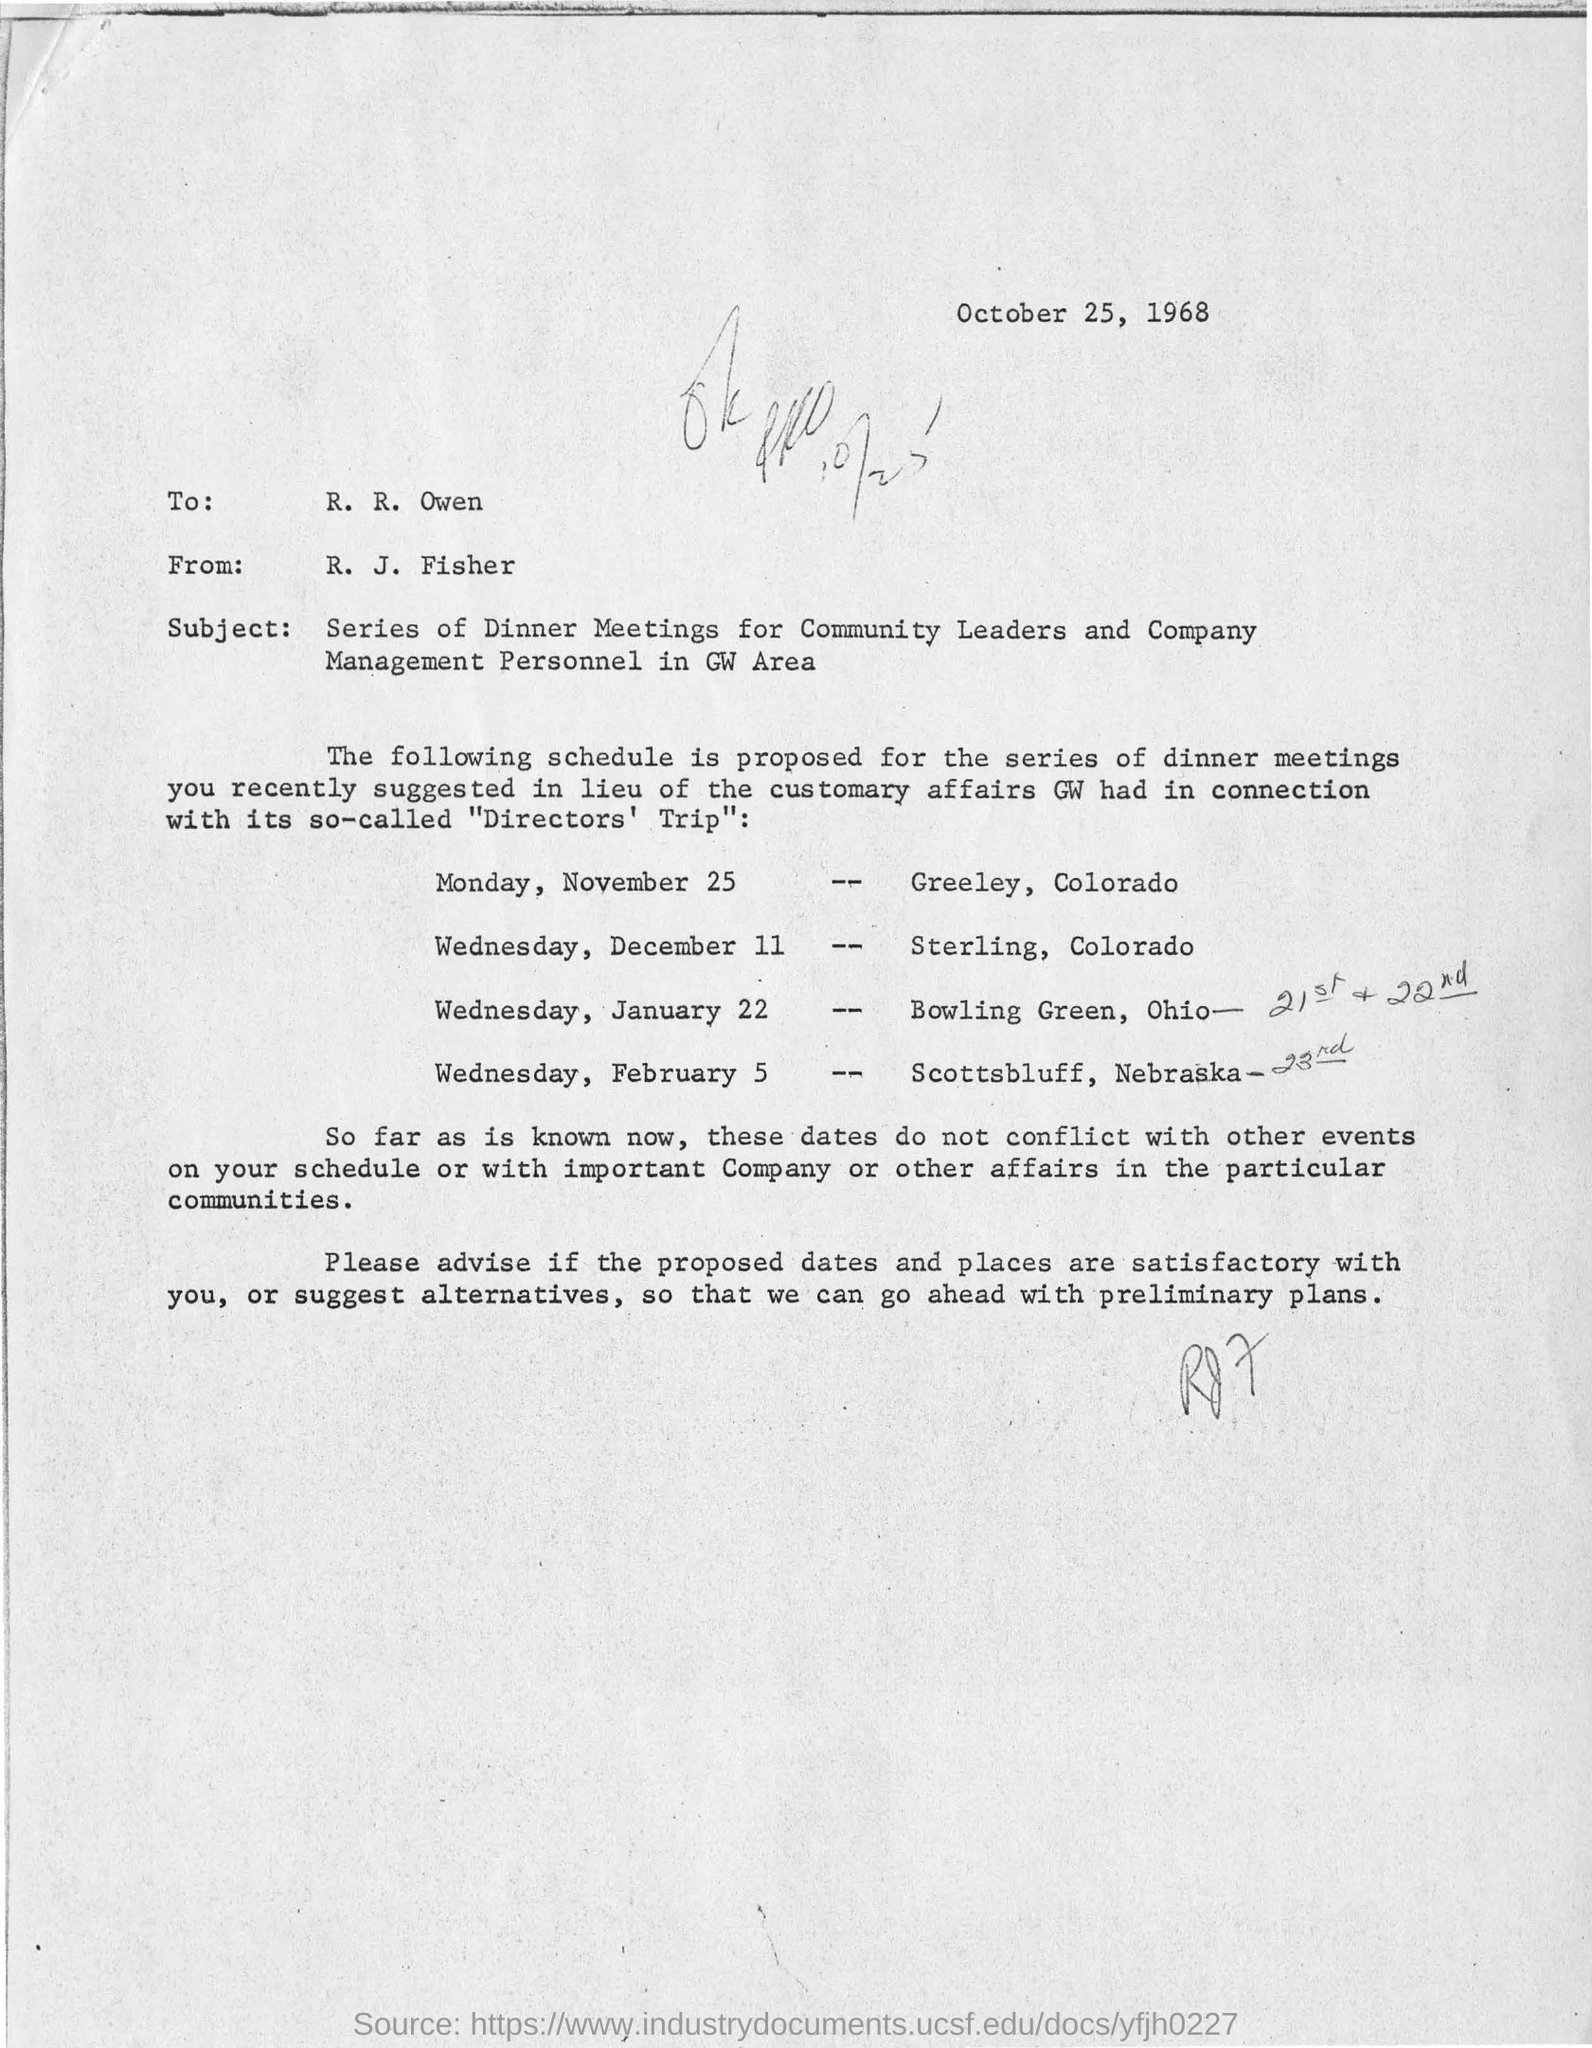Who is this letter from?
Provide a succinct answer. R. J. Fisher. To whom is the letter addressed to?
Your answer should be very brief. R. R. Owen. What is the date on the letter?
Your answer should be very brief. October 25, 1968. When is the dineer meeting for Greeley, Colorado?
Provide a succinct answer. Monday, november 25. 